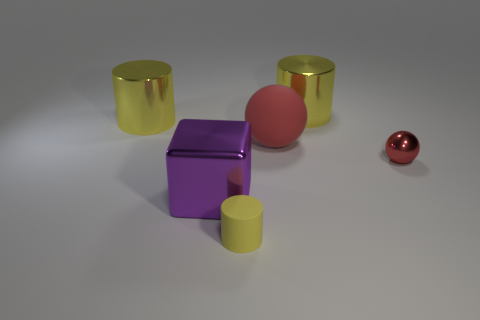Add 3 red shiny things. How many objects exist? 9 Subtract all balls. How many objects are left? 4 Subtract 0 purple spheres. How many objects are left? 6 Subtract all small matte things. Subtract all large red rubber balls. How many objects are left? 4 Add 3 tiny red spheres. How many tiny red spheres are left? 4 Add 4 big yellow cylinders. How many big yellow cylinders exist? 6 